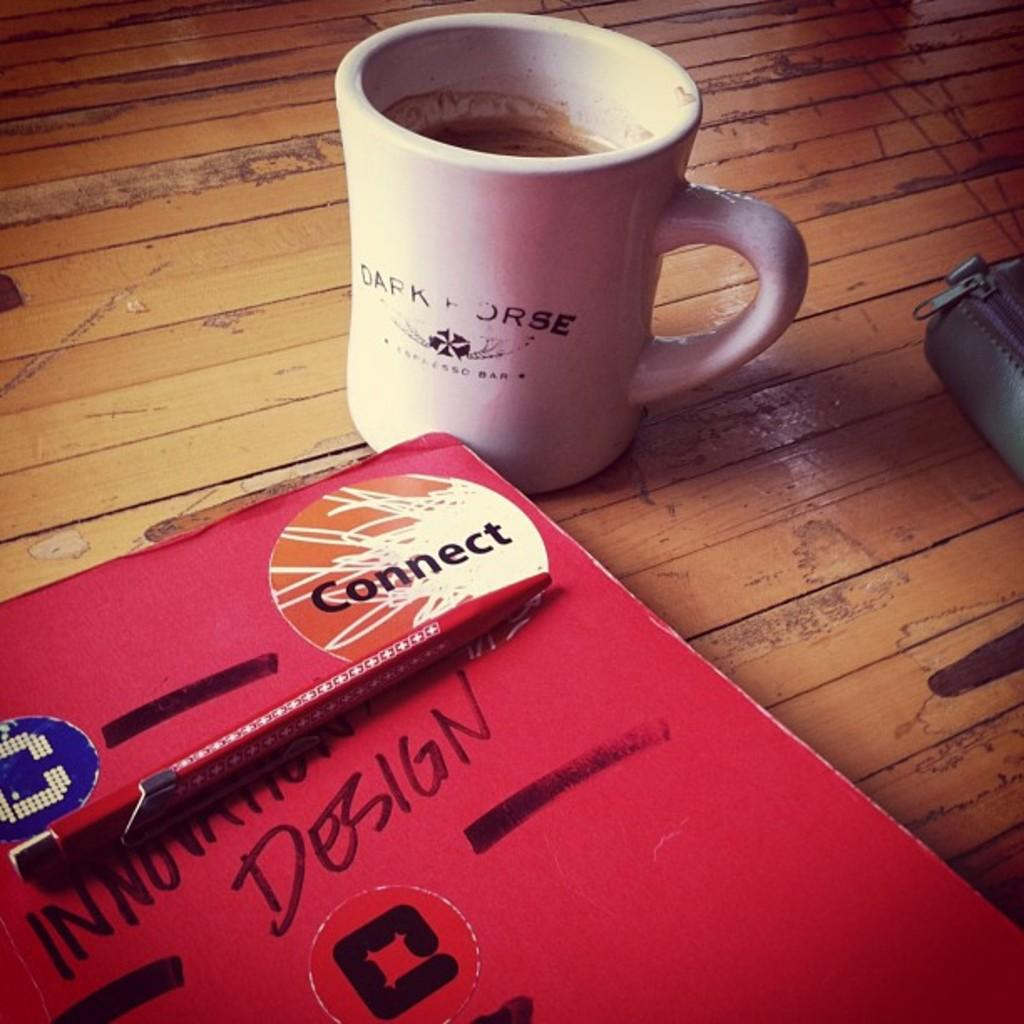<image>
Share a concise interpretation of the image provided. White cup of coffee that says Dark Horse next to a book. 